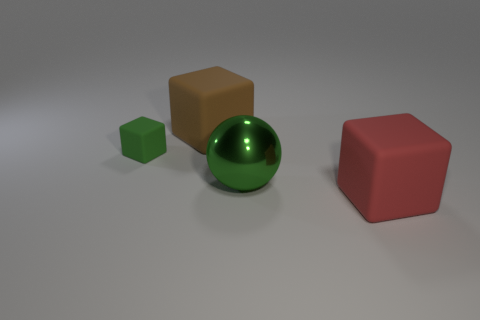Add 1 metallic objects. How many objects exist? 5 Subtract all cubes. How many objects are left? 1 Add 4 rubber blocks. How many rubber blocks exist? 7 Subtract 0 purple balls. How many objects are left? 4 Subtract all small things. Subtract all matte things. How many objects are left? 0 Add 2 green objects. How many green objects are left? 4 